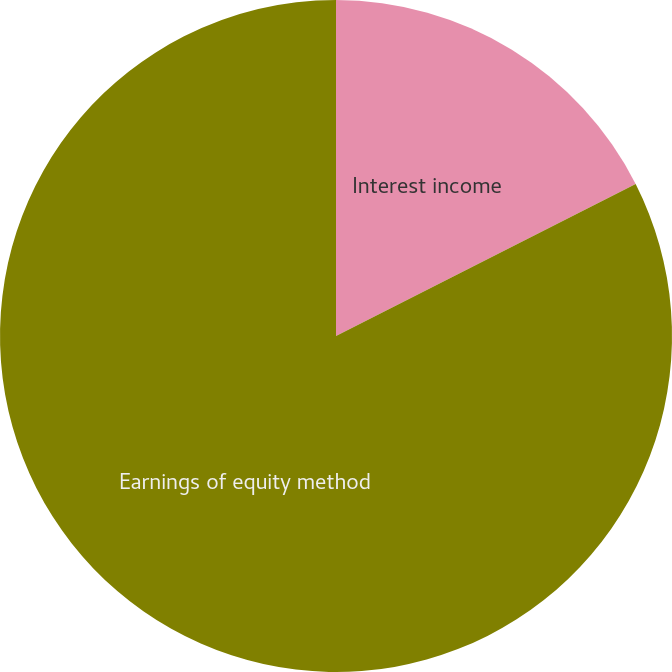Convert chart to OTSL. <chart><loc_0><loc_0><loc_500><loc_500><pie_chart><fcel>Interest income<fcel>Earnings of equity method<nl><fcel>17.53%<fcel>82.47%<nl></chart> 